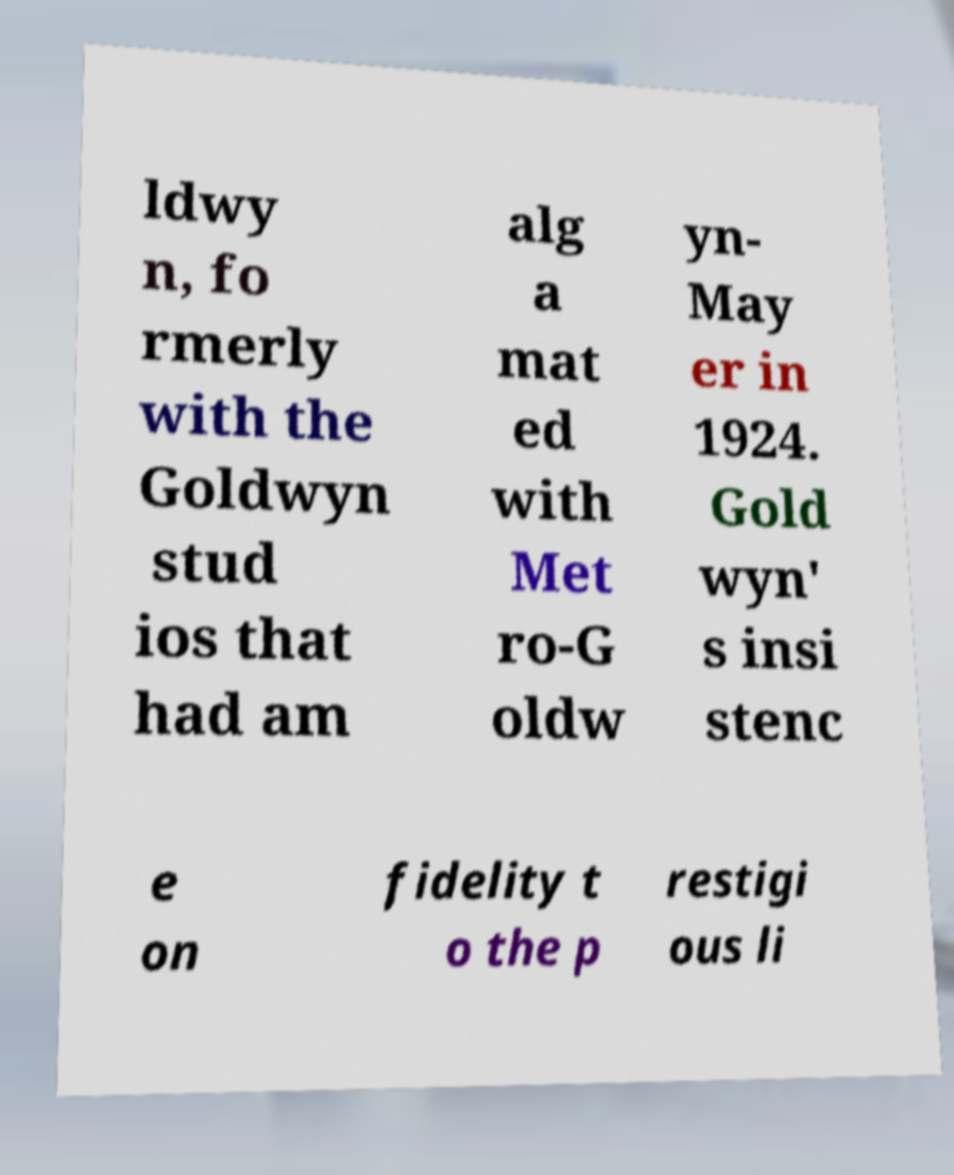I need the written content from this picture converted into text. Can you do that? ldwy n, fo rmerly with the Goldwyn stud ios that had am alg a mat ed with Met ro-G oldw yn- May er in 1924. Gold wyn' s insi stenc e on fidelity t o the p restigi ous li 